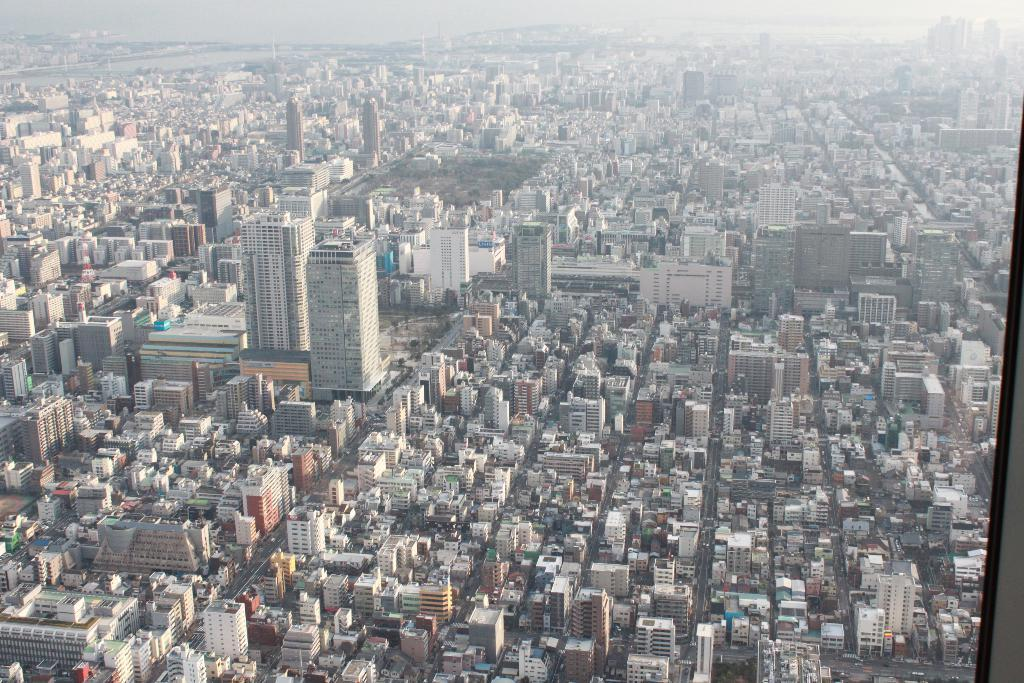What type of structures can be seen in the image? There are buildings in the image. What part of the natural environment is visible in the image? The sky is visible in the image. What type of coil can be seen in the image? There is no coil present in the image. How does the throat of the building appear in the image? Buildings do not have throats, so this question cannot be answered. 